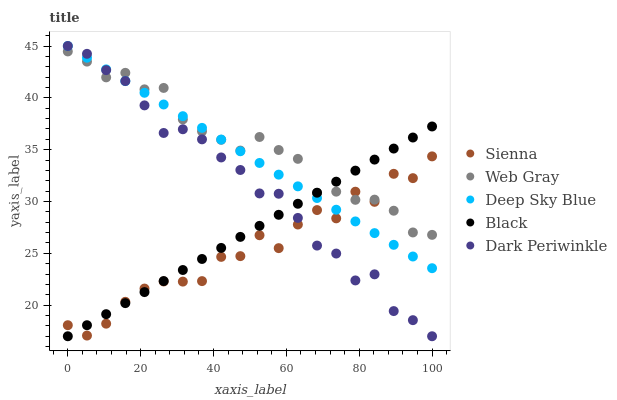Does Sienna have the minimum area under the curve?
Answer yes or no. Yes. Does Web Gray have the maximum area under the curve?
Answer yes or no. Yes. Does Black have the minimum area under the curve?
Answer yes or no. No. Does Black have the maximum area under the curve?
Answer yes or no. No. Is Deep Sky Blue the smoothest?
Answer yes or no. Yes. Is Sienna the roughest?
Answer yes or no. Yes. Is Web Gray the smoothest?
Answer yes or no. No. Is Web Gray the roughest?
Answer yes or no. No. Does Black have the lowest value?
Answer yes or no. Yes. Does Web Gray have the lowest value?
Answer yes or no. No. Does Deep Sky Blue have the highest value?
Answer yes or no. Yes. Does Web Gray have the highest value?
Answer yes or no. No. Does Web Gray intersect Deep Sky Blue?
Answer yes or no. Yes. Is Web Gray less than Deep Sky Blue?
Answer yes or no. No. Is Web Gray greater than Deep Sky Blue?
Answer yes or no. No. 